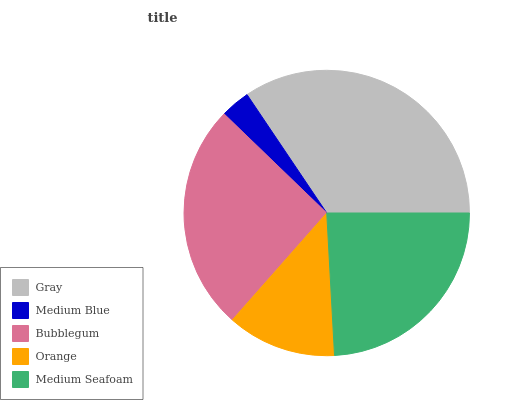Is Medium Blue the minimum?
Answer yes or no. Yes. Is Gray the maximum?
Answer yes or no. Yes. Is Bubblegum the minimum?
Answer yes or no. No. Is Bubblegum the maximum?
Answer yes or no. No. Is Bubblegum greater than Medium Blue?
Answer yes or no. Yes. Is Medium Blue less than Bubblegum?
Answer yes or no. Yes. Is Medium Blue greater than Bubblegum?
Answer yes or no. No. Is Bubblegum less than Medium Blue?
Answer yes or no. No. Is Medium Seafoam the high median?
Answer yes or no. Yes. Is Medium Seafoam the low median?
Answer yes or no. Yes. Is Medium Blue the high median?
Answer yes or no. No. Is Orange the low median?
Answer yes or no. No. 